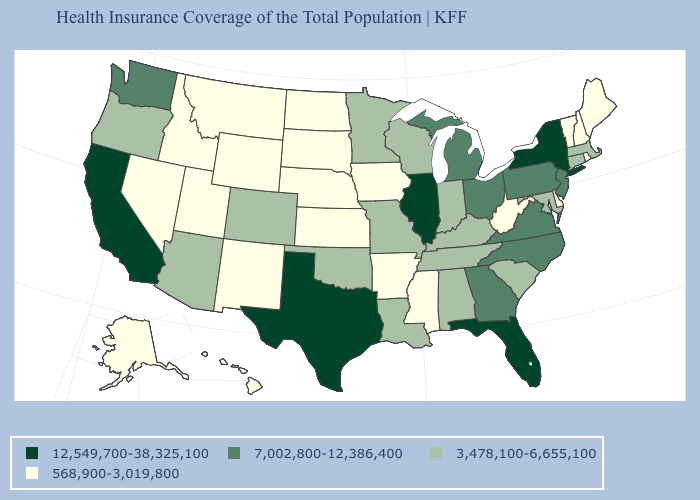Name the states that have a value in the range 3,478,100-6,655,100?
Give a very brief answer. Alabama, Arizona, Colorado, Connecticut, Indiana, Kentucky, Louisiana, Maryland, Massachusetts, Minnesota, Missouri, Oklahoma, Oregon, South Carolina, Tennessee, Wisconsin. Which states have the lowest value in the MidWest?
Be succinct. Iowa, Kansas, Nebraska, North Dakota, South Dakota. Is the legend a continuous bar?
Concise answer only. No. What is the value of Idaho?
Write a very short answer. 568,900-3,019,800. Name the states that have a value in the range 7,002,800-12,386,400?
Short answer required. Georgia, Michigan, New Jersey, North Carolina, Ohio, Pennsylvania, Virginia, Washington. Does Pennsylvania have the same value as North Carolina?
Keep it brief. Yes. Name the states that have a value in the range 7,002,800-12,386,400?
Keep it brief. Georgia, Michigan, New Jersey, North Carolina, Ohio, Pennsylvania, Virginia, Washington. What is the value of Arizona?
Give a very brief answer. 3,478,100-6,655,100. How many symbols are there in the legend?
Write a very short answer. 4. What is the value of Massachusetts?
Quick response, please. 3,478,100-6,655,100. What is the highest value in states that border Ohio?
Answer briefly. 7,002,800-12,386,400. What is the value of Georgia?
Concise answer only. 7,002,800-12,386,400. Name the states that have a value in the range 7,002,800-12,386,400?
Answer briefly. Georgia, Michigan, New Jersey, North Carolina, Ohio, Pennsylvania, Virginia, Washington. How many symbols are there in the legend?
Answer briefly. 4. What is the value of Montana?
Give a very brief answer. 568,900-3,019,800. 